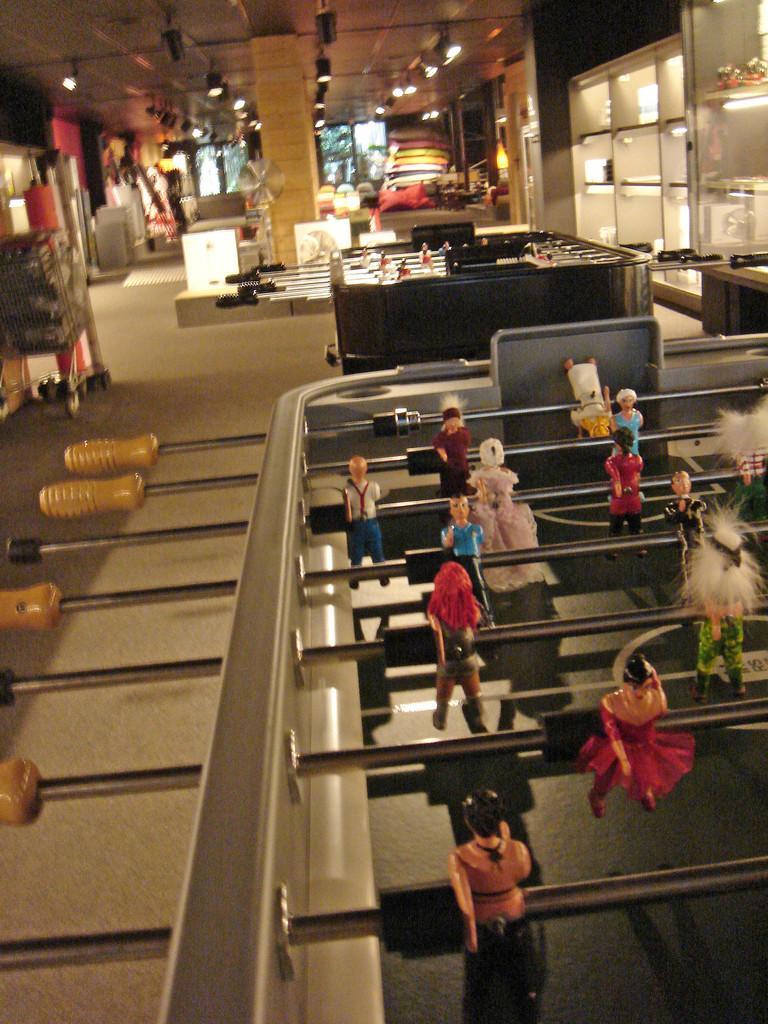In one or two sentences, can you explain what this image depicts? In this picture I can see mini soccer game boards, there are lights and some other objects. 